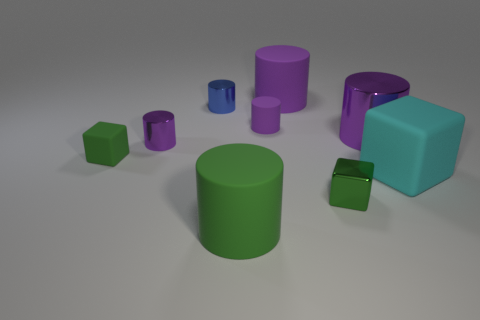How many purple cylinders must be subtracted to get 1 purple cylinders? 3 Subtract all green cubes. How many cubes are left? 1 Add 1 small green spheres. How many objects exist? 10 Subtract 3 cubes. How many cubes are left? 0 Subtract all cyan cubes. How many purple cylinders are left? 4 Subtract all green cylinders. How many cylinders are left? 5 Subtract 0 cyan balls. How many objects are left? 9 Subtract all cylinders. How many objects are left? 3 Subtract all red blocks. Subtract all gray spheres. How many blocks are left? 3 Subtract all green rubber cylinders. Subtract all large cyan things. How many objects are left? 7 